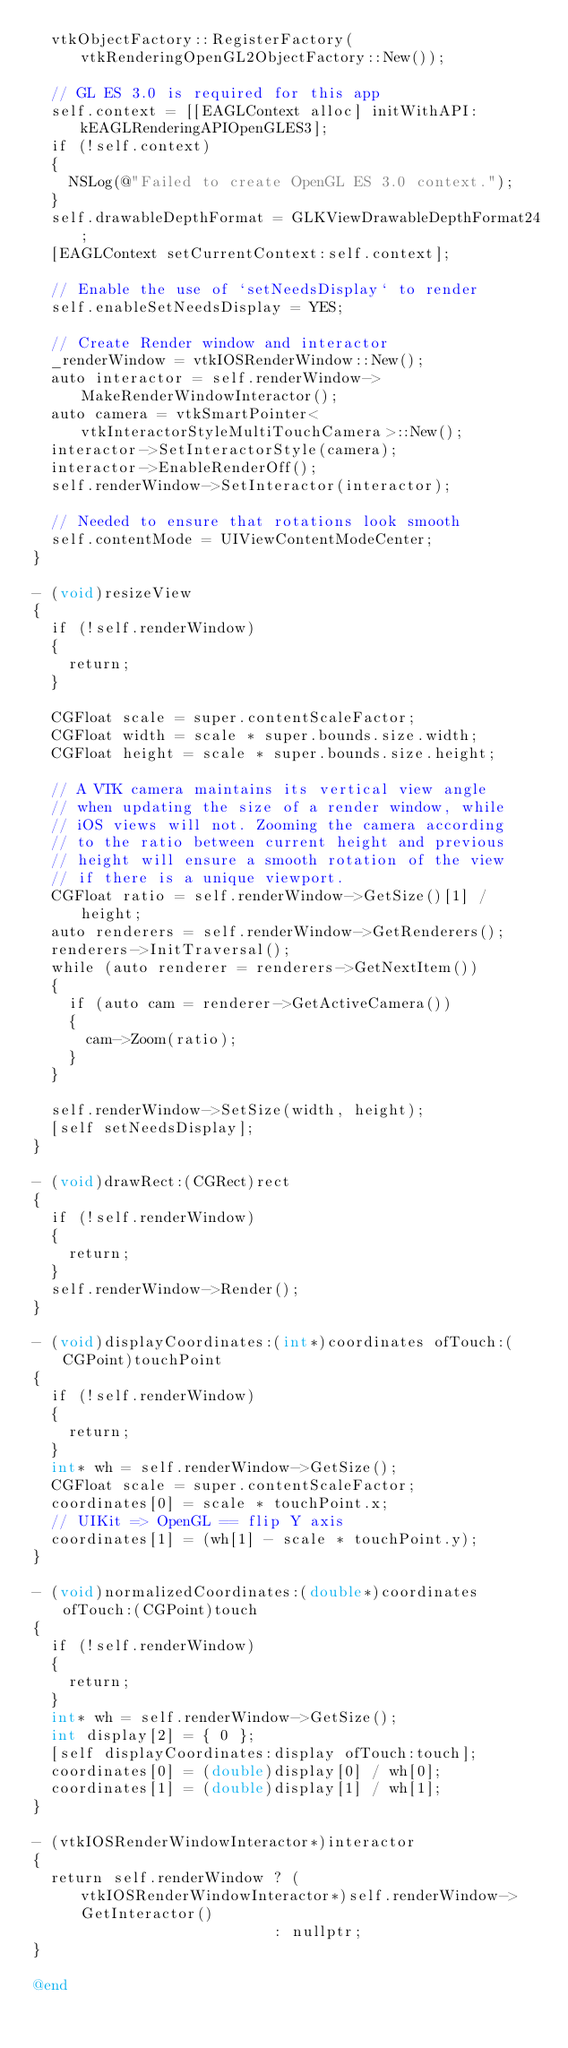Convert code to text. <code><loc_0><loc_0><loc_500><loc_500><_ObjectiveC_>  vtkObjectFactory::RegisterFactory(vtkRenderingOpenGL2ObjectFactory::New());

  // GL ES 3.0 is required for this app
  self.context = [[EAGLContext alloc] initWithAPI:kEAGLRenderingAPIOpenGLES3];
  if (!self.context)
  {
    NSLog(@"Failed to create OpenGL ES 3.0 context.");
  }
  self.drawableDepthFormat = GLKViewDrawableDepthFormat24;
  [EAGLContext setCurrentContext:self.context];

  // Enable the use of `setNeedsDisplay` to render
  self.enableSetNeedsDisplay = YES;

  // Create Render window and interactor
  _renderWindow = vtkIOSRenderWindow::New();
  auto interactor = self.renderWindow->MakeRenderWindowInteractor();
  auto camera = vtkSmartPointer<vtkInteractorStyleMultiTouchCamera>::New();
  interactor->SetInteractorStyle(camera);
  interactor->EnableRenderOff();
  self.renderWindow->SetInteractor(interactor);

  // Needed to ensure that rotations look smooth
  self.contentMode = UIViewContentModeCenter;
}

- (void)resizeView
{
  if (!self.renderWindow)
  {
    return;
  }

  CGFloat scale = super.contentScaleFactor;
  CGFloat width = scale * super.bounds.size.width;
  CGFloat height = scale * super.bounds.size.height;

  // A VTK camera maintains its vertical view angle
  // when updating the size of a render window, while
  // iOS views will not. Zooming the camera according
  // to the ratio between current height and previous
  // height will ensure a smooth rotation of the view
  // if there is a unique viewport.
  CGFloat ratio = self.renderWindow->GetSize()[1] / height;
  auto renderers = self.renderWindow->GetRenderers();
  renderers->InitTraversal();
  while (auto renderer = renderers->GetNextItem())
  {
    if (auto cam = renderer->GetActiveCamera())
    {
      cam->Zoom(ratio);
    }
  }

  self.renderWindow->SetSize(width, height);
  [self setNeedsDisplay];
}

- (void)drawRect:(CGRect)rect
{
  if (!self.renderWindow)
  {
    return;
  }
  self.renderWindow->Render();
}

- (void)displayCoordinates:(int*)coordinates ofTouch:(CGPoint)touchPoint
{
  if (!self.renderWindow)
  {
    return;
  }
  int* wh = self.renderWindow->GetSize();
  CGFloat scale = super.contentScaleFactor;
  coordinates[0] = scale * touchPoint.x;
  // UIKit => OpenGL == flip Y axis
  coordinates[1] = (wh[1] - scale * touchPoint.y);
}

- (void)normalizedCoordinates:(double*)coordinates ofTouch:(CGPoint)touch
{
  if (!self.renderWindow)
  {
    return;
  }
  int* wh = self.renderWindow->GetSize();
  int display[2] = { 0 };
  [self displayCoordinates:display ofTouch:touch];
  coordinates[0] = (double)display[0] / wh[0];
  coordinates[1] = (double)display[1] / wh[1];
}

- (vtkIOSRenderWindowInteractor*)interactor
{
  return self.renderWindow ? (vtkIOSRenderWindowInteractor*)self.renderWindow->GetInteractor()
                           : nullptr;
}

@end
</code> 